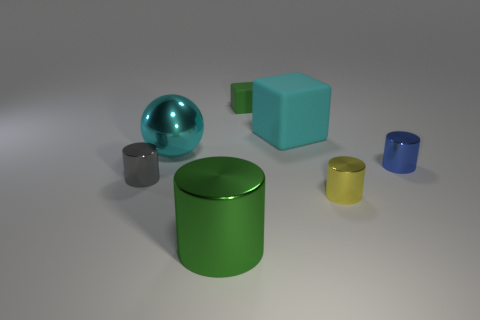There is a small thing to the left of the green thing behind the cylinder that is right of the yellow object; what color is it?
Give a very brief answer. Gray. How many small things are gray things or yellow objects?
Give a very brief answer. 2. Are there an equal number of big spheres in front of the large cylinder and small cylinders?
Provide a succinct answer. No. Are there any tiny metal objects behind the tiny rubber block?
Ensure brevity in your answer.  No. What number of shiny objects are big objects or tiny yellow blocks?
Provide a short and direct response. 2. There is a large cyan matte object; what number of large cyan rubber things are behind it?
Keep it short and to the point. 0. Are there any gray shiny cylinders that have the same size as the cyan metallic ball?
Give a very brief answer. No. Is there a rubber block that has the same color as the large rubber thing?
Provide a short and direct response. No. Is there anything else that is the same size as the gray cylinder?
Your response must be concise. Yes. What number of other cubes have the same color as the large rubber block?
Offer a very short reply. 0. 